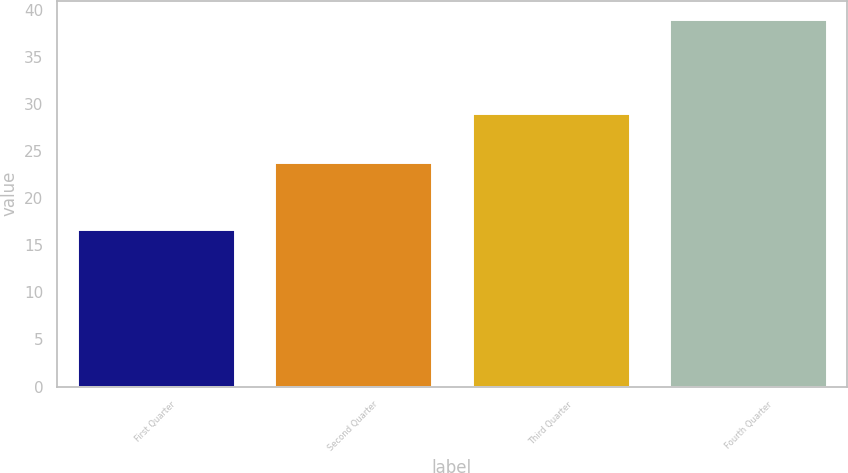Convert chart. <chart><loc_0><loc_0><loc_500><loc_500><bar_chart><fcel>First Quarter<fcel>Second Quarter<fcel>Third Quarter<fcel>Fourth Quarter<nl><fcel>16.7<fcel>23.85<fcel>29.06<fcel>39.01<nl></chart> 